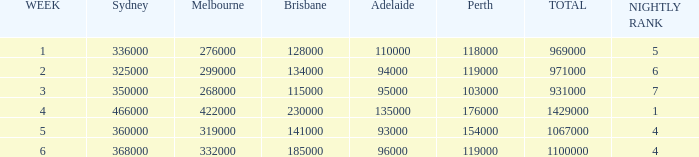What was the ranking in brisbane during the week it was 276000 in melbourne? 128000.0. 